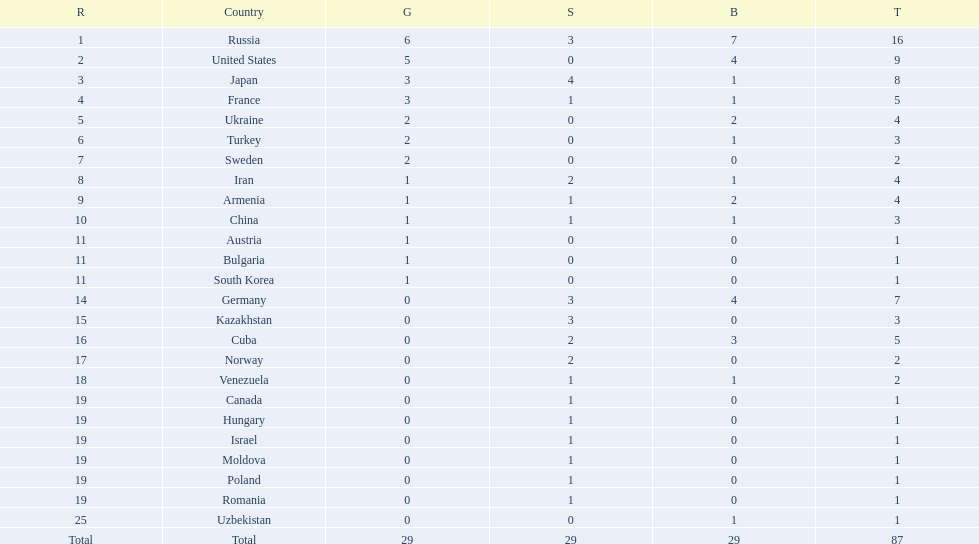Which nations participated in the 1995 world wrestling championships? Russia, United States, Japan, France, Ukraine, Turkey, Sweden, Iran, Armenia, China, Austria, Bulgaria, South Korea, Germany, Kazakhstan, Cuba, Norway, Venezuela, Canada, Hungary, Israel, Moldova, Poland, Romania, Uzbekistan. And between iran and germany, which one placed in the top 10? Germany. 